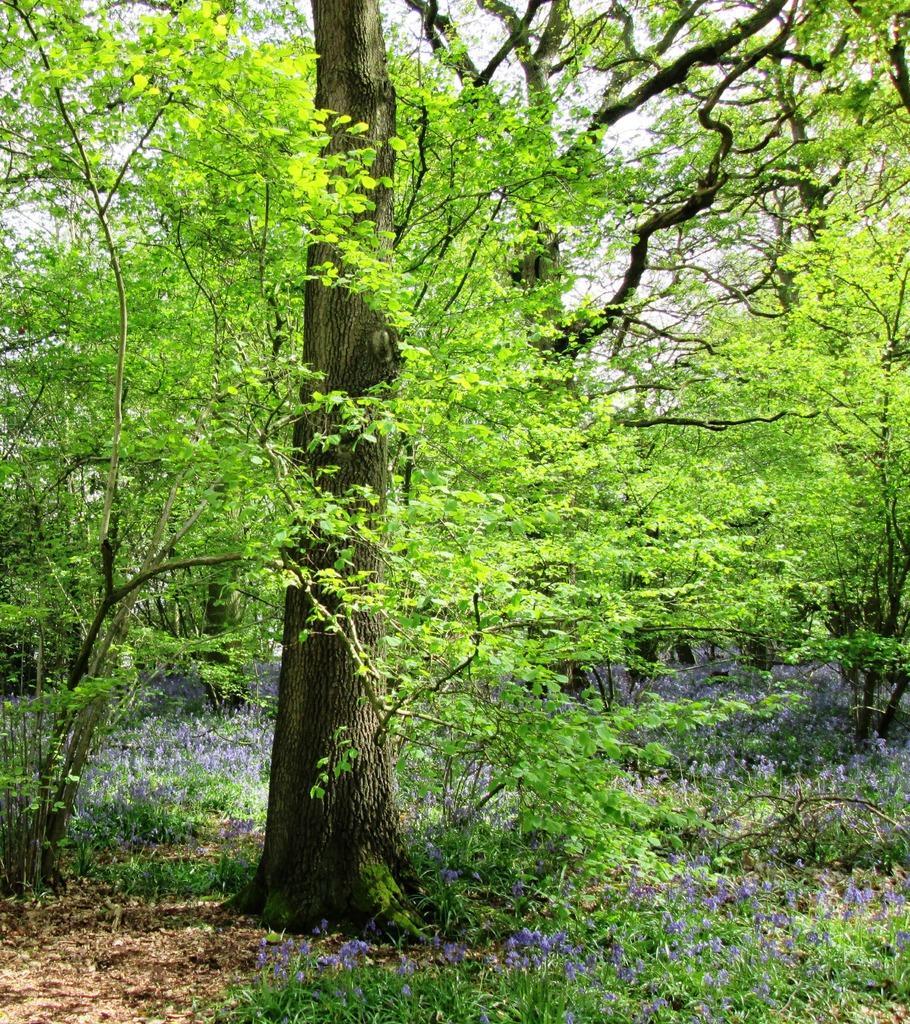Please provide a concise description of this image. In this picture I can observe trees in the middle of the picture. There are are some plants on the ground. In the background there is sky. 